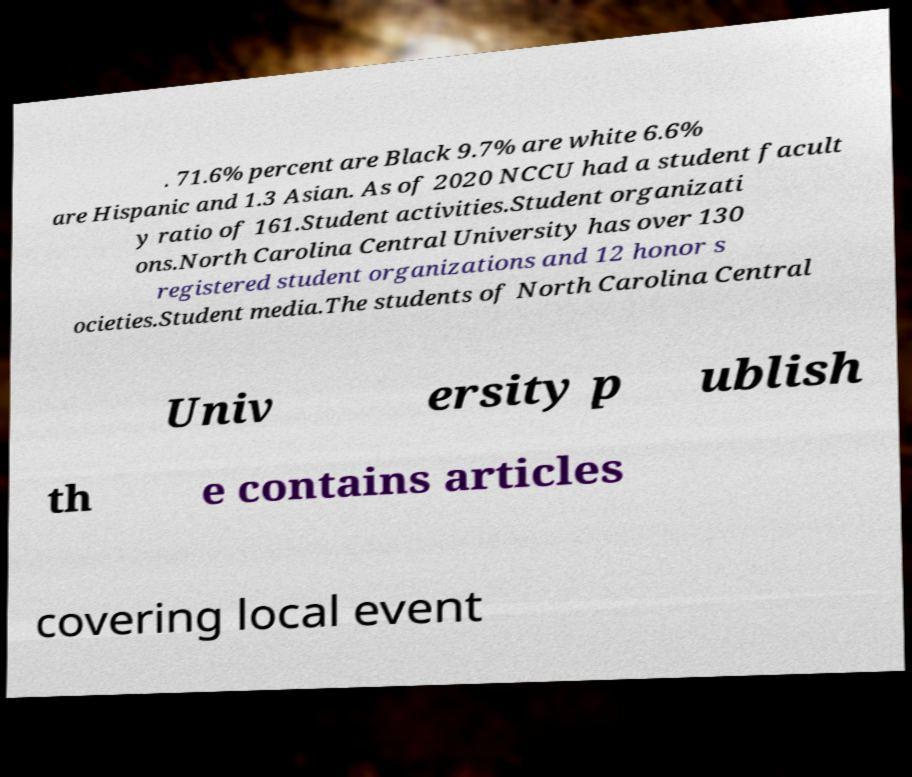Could you assist in decoding the text presented in this image and type it out clearly? . 71.6% percent are Black 9.7% are white 6.6% are Hispanic and 1.3 Asian. As of 2020 NCCU had a student facult y ratio of 161.Student activities.Student organizati ons.North Carolina Central University has over 130 registered student organizations and 12 honor s ocieties.Student media.The students of North Carolina Central Univ ersity p ublish th e contains articles covering local event 